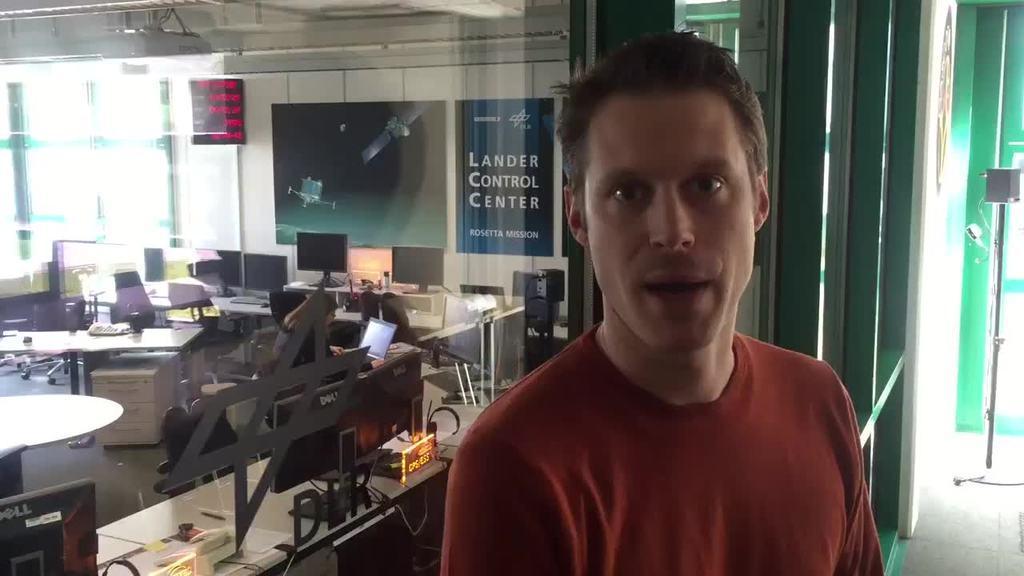In one or two sentences, can you explain what this image depicts? In this picture there is a man who is wearing t-shirt. She is standing near the door and glass partition. On the left I can see many tables. On the table I can see the laptops, computer screens, keyboards and mouse. In the background I can see some cotton boxes which are kept on the floor and posters on the wall. 